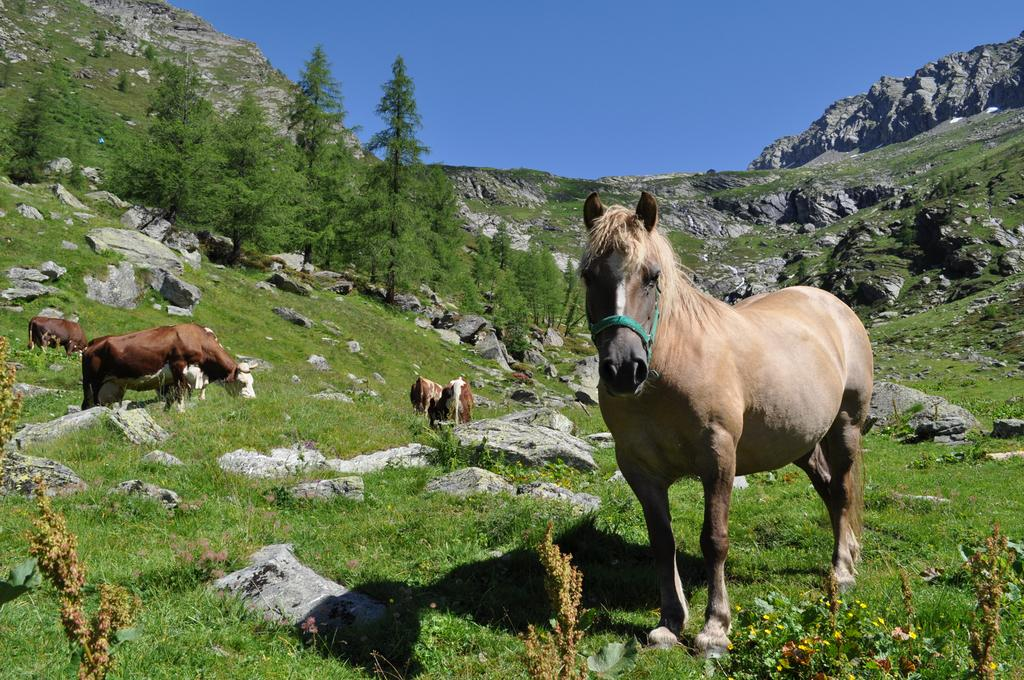What type of living organisms can be seen in the image? There are animals in the image. What type of vegetation is present in the image? There is grass in the image. What other natural elements can be seen in the image? There are rocks in the image. What can be seen in the background of the image? There are trees and hills in the background of the image. What type of gold ornaments are the animals wearing in the image? There is no mention of gold ornaments in the image; the animals are not wearing any ornaments. 